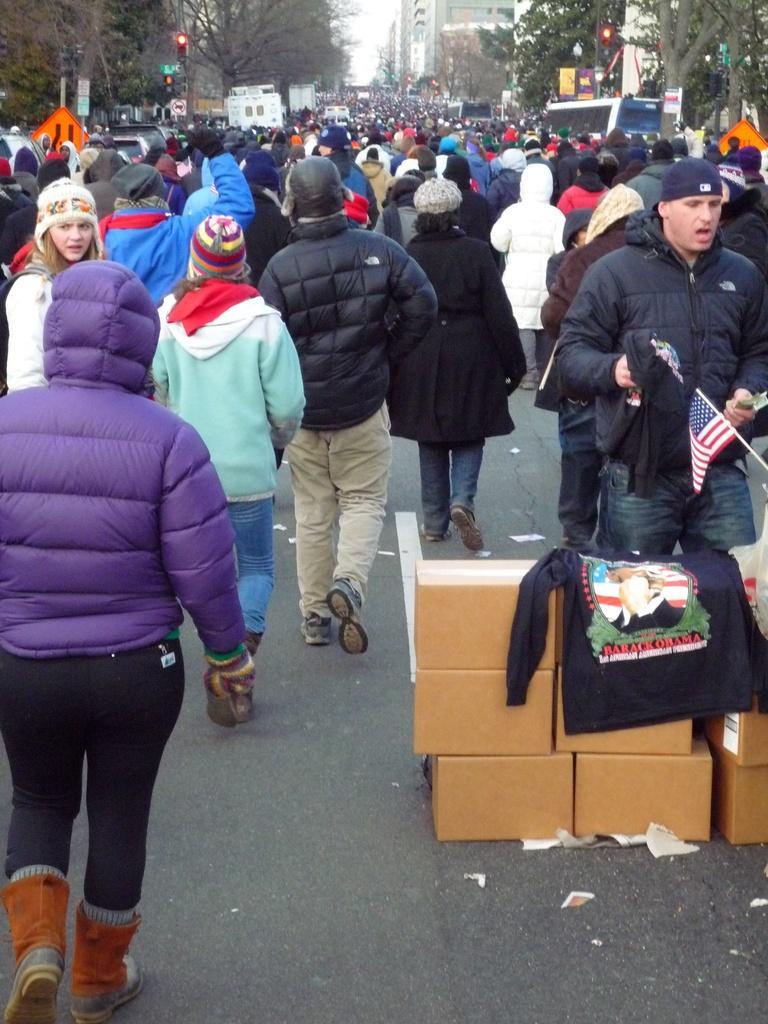Could you give a brief overview of what you see in this image? This picture describes about group of people, few people wore caps, on the right side of the image we can find few boxes, in the background we can find few traffic lights, trees, vehicles and buildings. 